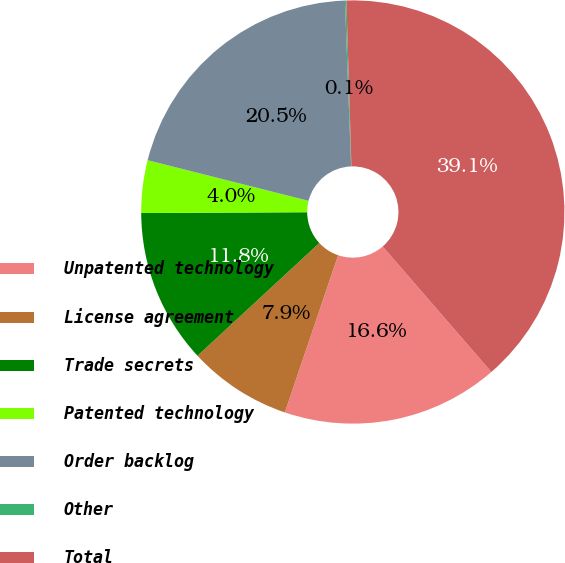Convert chart to OTSL. <chart><loc_0><loc_0><loc_500><loc_500><pie_chart><fcel>Unpatented technology<fcel>License agreement<fcel>Trade secrets<fcel>Patented technology<fcel>Order backlog<fcel>Other<fcel>Total<nl><fcel>16.56%<fcel>7.91%<fcel>11.81%<fcel>4.01%<fcel>20.47%<fcel>0.11%<fcel>39.12%<nl></chart> 